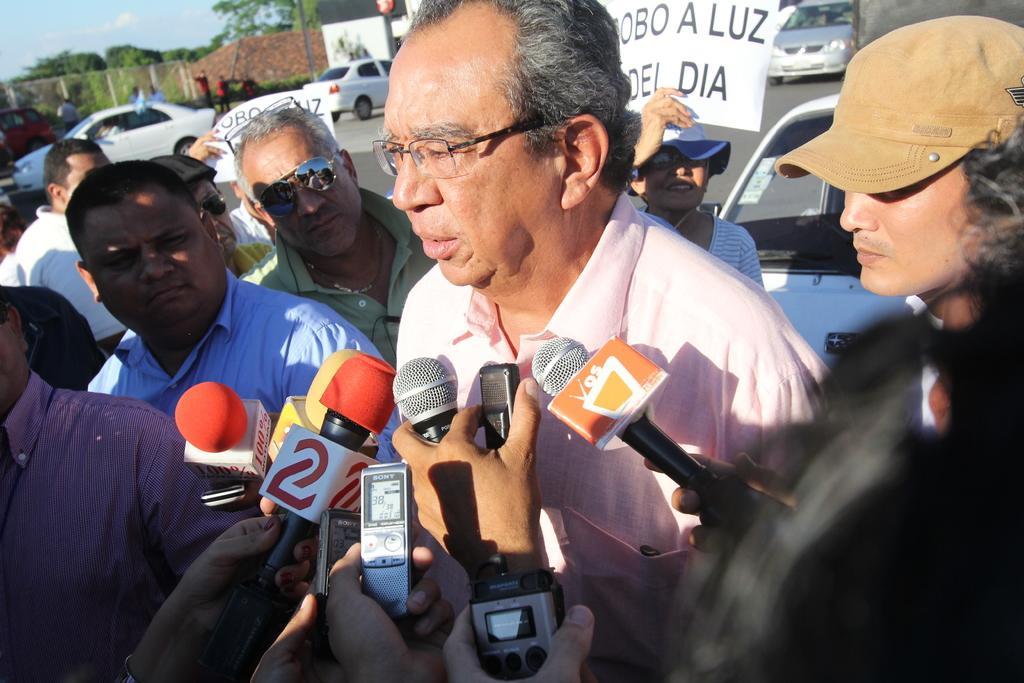In one or two sentences, can you explain what this image depicts? In this picture, we see a group of people are standing. The man in the middle of the picture is standing and he is talking on the microphone. In front of him, we see microphones and recorders. Behind him, we see a woman in white T-shirt is holding a paper with some text written on it. Behind her, we see a white car. In the background, there are cars moving on the road. Beside that, people are standing. In the background, we see a fence, building and trees. 